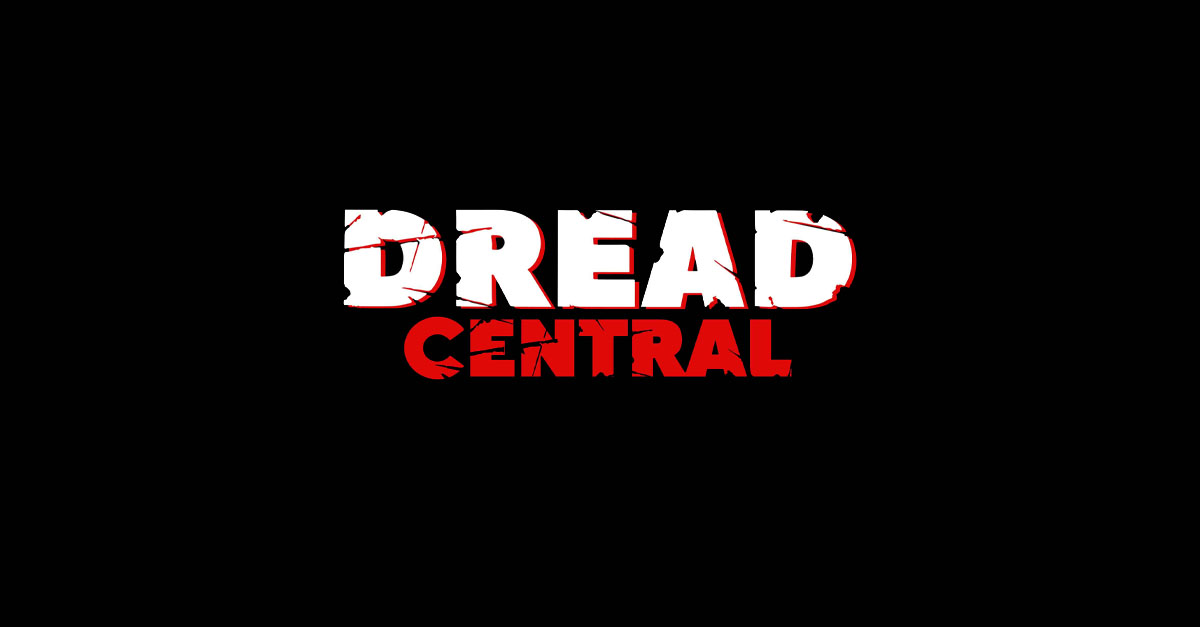Considering the stylistic choices made in the text design, what genre or themes might the entity represented by this text be associated with, and why do these design choices suggest that? The genre or themes suggested by the text design are likely related to horror, suspense, or thriller. The use of the word "DREAD" immediately conveys a sense of fear or apprehension. The cracked and broken style of the text, along with the bold typeface and stark color contrast, reinforce this impression. The red color is often associated with danger or warning, which aligns with the horror genre. Additionally, the distressed look of the text can indicate a connection to themes of decay or disturbance, which are common in horror-themed content. 